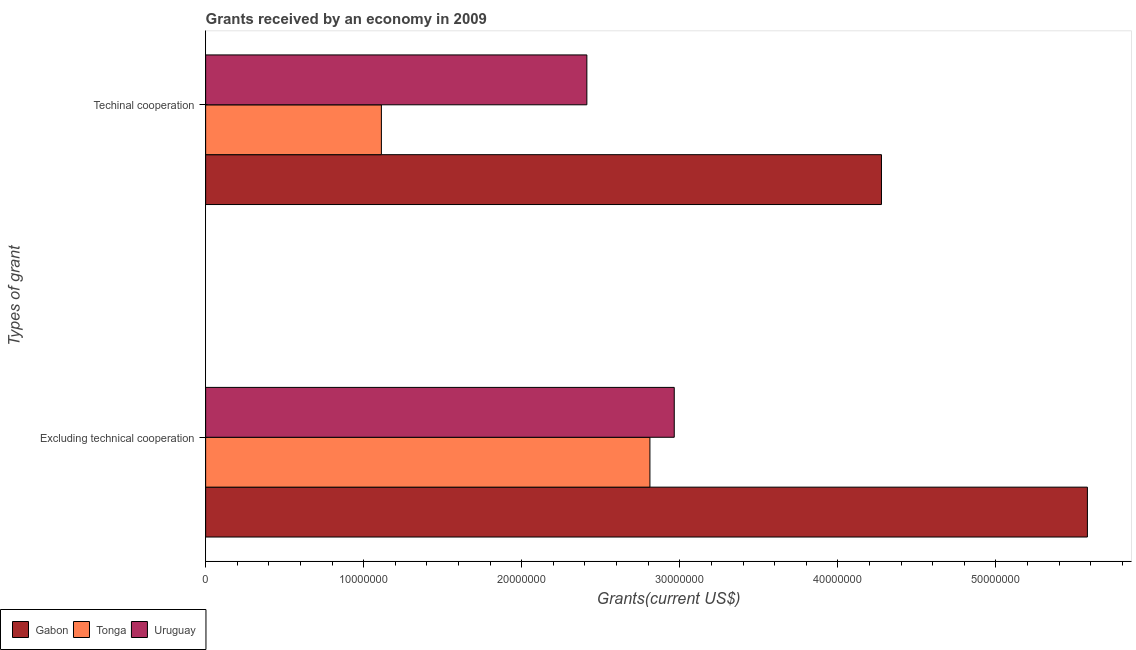Are the number of bars per tick equal to the number of legend labels?
Provide a short and direct response. Yes. Are the number of bars on each tick of the Y-axis equal?
Make the answer very short. Yes. How many bars are there on the 1st tick from the bottom?
Provide a short and direct response. 3. What is the label of the 1st group of bars from the top?
Provide a short and direct response. Techinal cooperation. What is the amount of grants received(including technical cooperation) in Gabon?
Keep it short and to the point. 4.28e+07. Across all countries, what is the maximum amount of grants received(including technical cooperation)?
Ensure brevity in your answer.  4.28e+07. Across all countries, what is the minimum amount of grants received(including technical cooperation)?
Make the answer very short. 1.11e+07. In which country was the amount of grants received(including technical cooperation) maximum?
Offer a very short reply. Gabon. In which country was the amount of grants received(including technical cooperation) minimum?
Offer a terse response. Tonga. What is the total amount of grants received(including technical cooperation) in the graph?
Your answer should be very brief. 7.80e+07. What is the difference between the amount of grants received(including technical cooperation) in Gabon and that in Uruguay?
Make the answer very short. 1.86e+07. What is the difference between the amount of grants received(including technical cooperation) in Tonga and the amount of grants received(excluding technical cooperation) in Uruguay?
Provide a succinct answer. -1.85e+07. What is the average amount of grants received(including technical cooperation) per country?
Offer a terse response. 2.60e+07. What is the difference between the amount of grants received(including technical cooperation) and amount of grants received(excluding technical cooperation) in Tonga?
Offer a terse response. -1.70e+07. What is the ratio of the amount of grants received(including technical cooperation) in Uruguay to that in Gabon?
Your answer should be very brief. 0.56. Is the amount of grants received(including technical cooperation) in Gabon less than that in Uruguay?
Your answer should be very brief. No. What does the 3rd bar from the top in Excluding technical cooperation represents?
Give a very brief answer. Gabon. What does the 1st bar from the bottom in Excluding technical cooperation represents?
Ensure brevity in your answer.  Gabon. How many bars are there?
Make the answer very short. 6. What is the difference between two consecutive major ticks on the X-axis?
Give a very brief answer. 1.00e+07. Are the values on the major ticks of X-axis written in scientific E-notation?
Provide a succinct answer. No. Does the graph contain any zero values?
Provide a short and direct response. No. Where does the legend appear in the graph?
Ensure brevity in your answer.  Bottom left. How are the legend labels stacked?
Ensure brevity in your answer.  Horizontal. What is the title of the graph?
Keep it short and to the point. Grants received by an economy in 2009. What is the label or title of the X-axis?
Provide a short and direct response. Grants(current US$). What is the label or title of the Y-axis?
Your answer should be very brief. Types of grant. What is the Grants(current US$) of Gabon in Excluding technical cooperation?
Ensure brevity in your answer.  5.58e+07. What is the Grants(current US$) in Tonga in Excluding technical cooperation?
Offer a terse response. 2.81e+07. What is the Grants(current US$) in Uruguay in Excluding technical cooperation?
Make the answer very short. 2.96e+07. What is the Grants(current US$) in Gabon in Techinal cooperation?
Offer a terse response. 4.28e+07. What is the Grants(current US$) of Tonga in Techinal cooperation?
Offer a very short reply. 1.11e+07. What is the Grants(current US$) in Uruguay in Techinal cooperation?
Offer a very short reply. 2.41e+07. Across all Types of grant, what is the maximum Grants(current US$) of Gabon?
Make the answer very short. 5.58e+07. Across all Types of grant, what is the maximum Grants(current US$) of Tonga?
Provide a short and direct response. 2.81e+07. Across all Types of grant, what is the maximum Grants(current US$) of Uruguay?
Your response must be concise. 2.96e+07. Across all Types of grant, what is the minimum Grants(current US$) in Gabon?
Make the answer very short. 4.28e+07. Across all Types of grant, what is the minimum Grants(current US$) in Tonga?
Give a very brief answer. 1.11e+07. Across all Types of grant, what is the minimum Grants(current US$) in Uruguay?
Offer a terse response. 2.41e+07. What is the total Grants(current US$) of Gabon in the graph?
Make the answer very short. 9.86e+07. What is the total Grants(current US$) of Tonga in the graph?
Your answer should be very brief. 3.92e+07. What is the total Grants(current US$) of Uruguay in the graph?
Offer a very short reply. 5.38e+07. What is the difference between the Grants(current US$) in Gabon in Excluding technical cooperation and that in Techinal cooperation?
Offer a very short reply. 1.30e+07. What is the difference between the Grants(current US$) in Tonga in Excluding technical cooperation and that in Techinal cooperation?
Provide a short and direct response. 1.70e+07. What is the difference between the Grants(current US$) of Uruguay in Excluding technical cooperation and that in Techinal cooperation?
Your answer should be compact. 5.53e+06. What is the difference between the Grants(current US$) of Gabon in Excluding technical cooperation and the Grants(current US$) of Tonga in Techinal cooperation?
Ensure brevity in your answer.  4.47e+07. What is the difference between the Grants(current US$) of Gabon in Excluding technical cooperation and the Grants(current US$) of Uruguay in Techinal cooperation?
Your answer should be very brief. 3.17e+07. What is the difference between the Grants(current US$) in Tonga in Excluding technical cooperation and the Grants(current US$) in Uruguay in Techinal cooperation?
Provide a short and direct response. 3.99e+06. What is the average Grants(current US$) in Gabon per Types of grant?
Provide a short and direct response. 4.93e+07. What is the average Grants(current US$) of Tonga per Types of grant?
Your answer should be compact. 1.96e+07. What is the average Grants(current US$) in Uruguay per Types of grant?
Ensure brevity in your answer.  2.69e+07. What is the difference between the Grants(current US$) in Gabon and Grants(current US$) in Tonga in Excluding technical cooperation?
Your answer should be very brief. 2.77e+07. What is the difference between the Grants(current US$) of Gabon and Grants(current US$) of Uruguay in Excluding technical cooperation?
Offer a terse response. 2.61e+07. What is the difference between the Grants(current US$) of Tonga and Grants(current US$) of Uruguay in Excluding technical cooperation?
Offer a terse response. -1.54e+06. What is the difference between the Grants(current US$) in Gabon and Grants(current US$) in Tonga in Techinal cooperation?
Offer a terse response. 3.16e+07. What is the difference between the Grants(current US$) in Gabon and Grants(current US$) in Uruguay in Techinal cooperation?
Ensure brevity in your answer.  1.86e+07. What is the difference between the Grants(current US$) of Tonga and Grants(current US$) of Uruguay in Techinal cooperation?
Keep it short and to the point. -1.30e+07. What is the ratio of the Grants(current US$) in Gabon in Excluding technical cooperation to that in Techinal cooperation?
Provide a succinct answer. 1.3. What is the ratio of the Grants(current US$) of Tonga in Excluding technical cooperation to that in Techinal cooperation?
Ensure brevity in your answer.  2.53. What is the ratio of the Grants(current US$) of Uruguay in Excluding technical cooperation to that in Techinal cooperation?
Provide a succinct answer. 1.23. What is the difference between the highest and the second highest Grants(current US$) in Gabon?
Your answer should be compact. 1.30e+07. What is the difference between the highest and the second highest Grants(current US$) of Tonga?
Provide a short and direct response. 1.70e+07. What is the difference between the highest and the second highest Grants(current US$) in Uruguay?
Your response must be concise. 5.53e+06. What is the difference between the highest and the lowest Grants(current US$) in Gabon?
Ensure brevity in your answer.  1.30e+07. What is the difference between the highest and the lowest Grants(current US$) in Tonga?
Provide a succinct answer. 1.70e+07. What is the difference between the highest and the lowest Grants(current US$) of Uruguay?
Provide a succinct answer. 5.53e+06. 